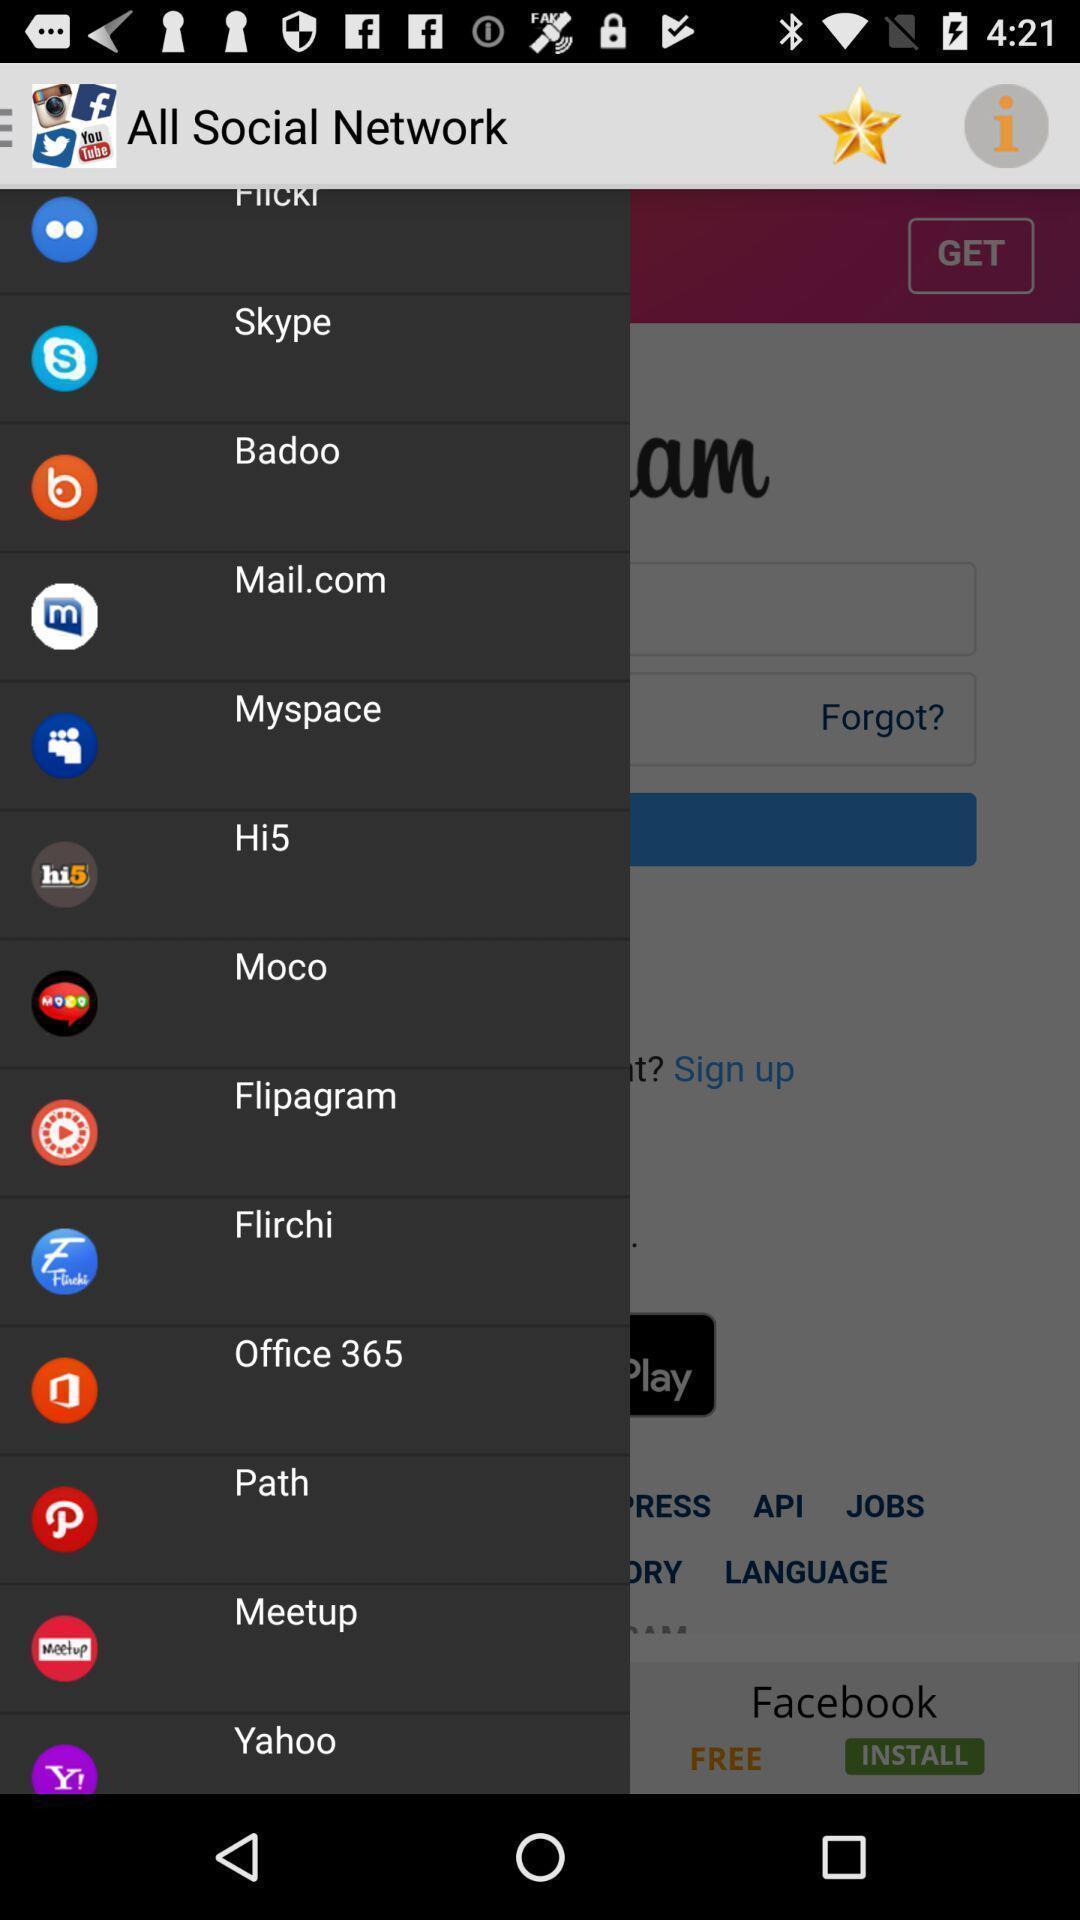Please provide a description for this image. Pop-up displaying the list of all social apps. 